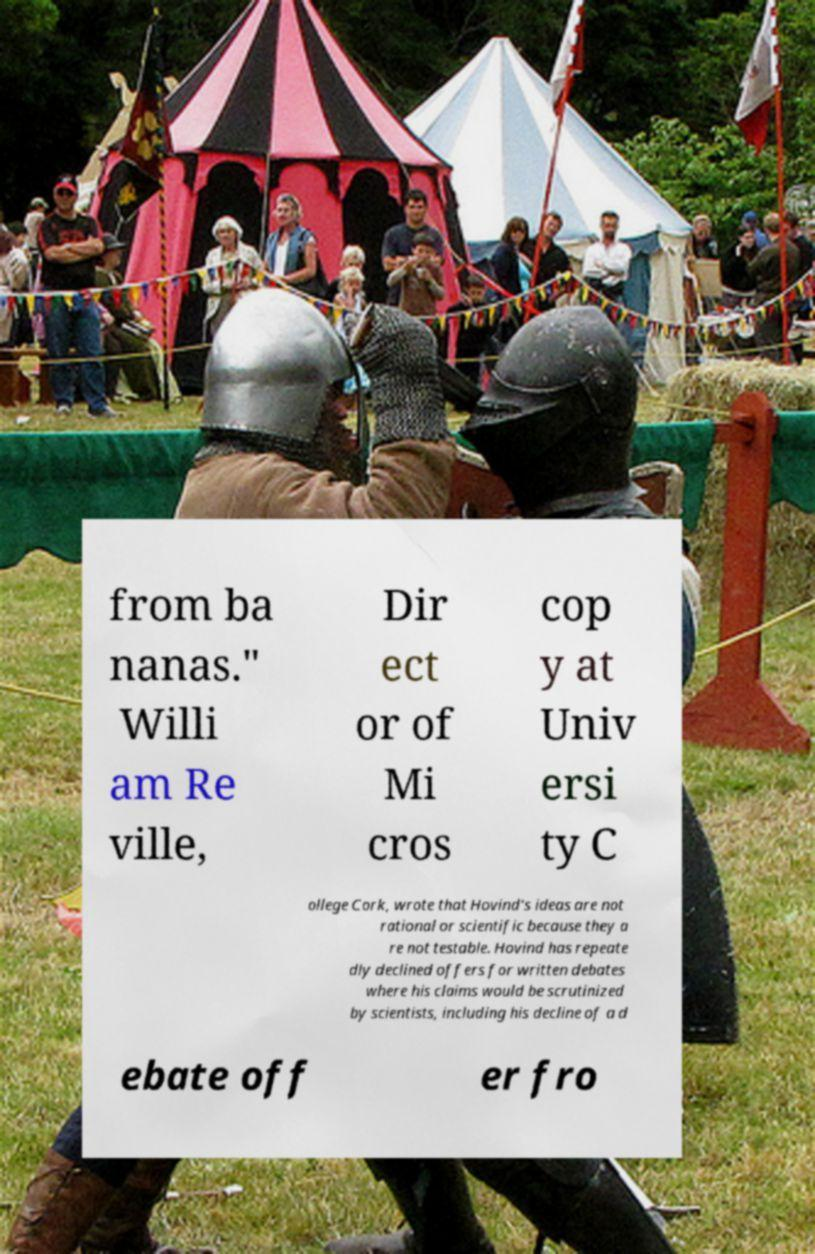Can you read and provide the text displayed in the image?This photo seems to have some interesting text. Can you extract and type it out for me? from ba nanas." Willi am Re ville, Dir ect or of Mi cros cop y at Univ ersi ty C ollege Cork, wrote that Hovind's ideas are not rational or scientific because they a re not testable. Hovind has repeate dly declined offers for written debates where his claims would be scrutinized by scientists, including his decline of a d ebate off er fro 